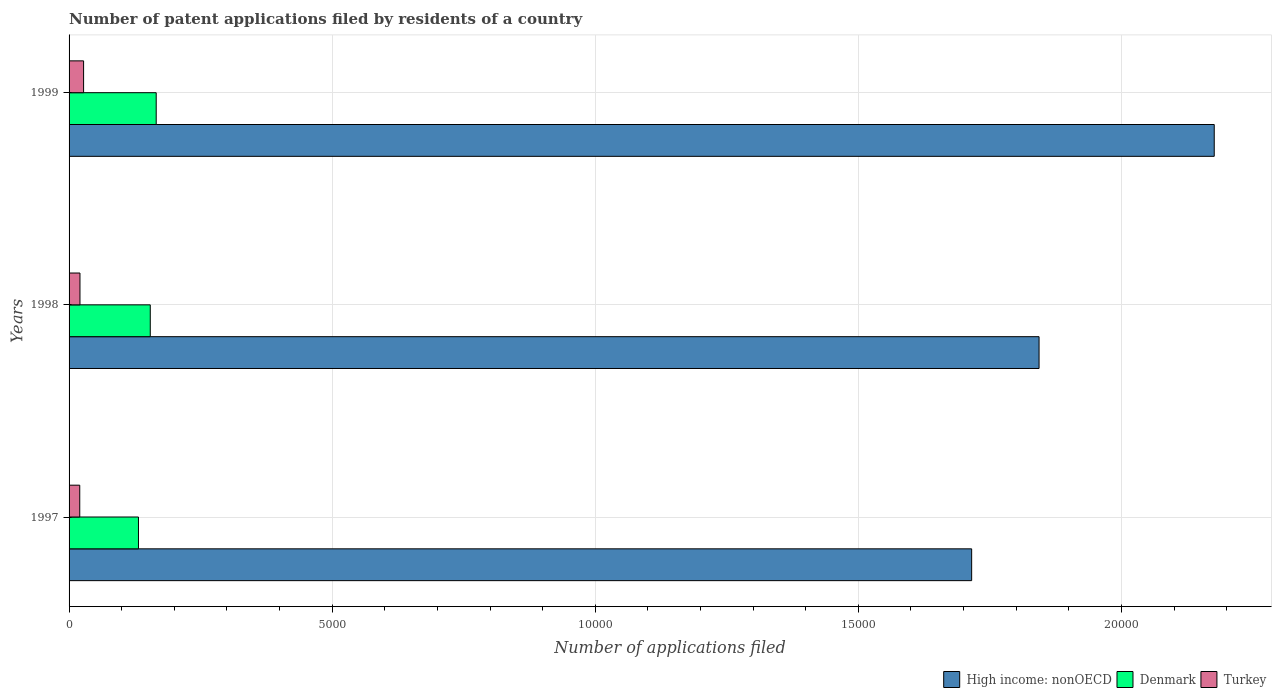How many different coloured bars are there?
Your answer should be very brief. 3. How many groups of bars are there?
Give a very brief answer. 3. Are the number of bars on each tick of the Y-axis equal?
Ensure brevity in your answer.  Yes. In how many cases, is the number of bars for a given year not equal to the number of legend labels?
Your answer should be compact. 0. What is the number of applications filed in Turkey in 1999?
Your answer should be very brief. 276. Across all years, what is the maximum number of applications filed in Turkey?
Offer a terse response. 276. Across all years, what is the minimum number of applications filed in Turkey?
Ensure brevity in your answer.  203. In which year was the number of applications filed in Denmark minimum?
Your answer should be very brief. 1997. What is the total number of applications filed in Turkey in the graph?
Your answer should be very brief. 686. What is the difference between the number of applications filed in High income: nonOECD in 1997 and that in 1999?
Your answer should be compact. -4610. What is the difference between the number of applications filed in Turkey in 1998 and the number of applications filed in Denmark in 1997?
Your response must be concise. -1112. What is the average number of applications filed in High income: nonOECD per year?
Offer a terse response. 1.91e+04. In the year 1998, what is the difference between the number of applications filed in High income: nonOECD and number of applications filed in Denmark?
Your response must be concise. 1.69e+04. In how many years, is the number of applications filed in Turkey greater than 14000 ?
Provide a succinct answer. 0. What is the ratio of the number of applications filed in Denmark in 1998 to that in 1999?
Provide a succinct answer. 0.93. Is the number of applications filed in Turkey in 1998 less than that in 1999?
Keep it short and to the point. Yes. Is the difference between the number of applications filed in High income: nonOECD in 1997 and 1998 greater than the difference between the number of applications filed in Denmark in 1997 and 1998?
Keep it short and to the point. No. What is the difference between the highest and the second highest number of applications filed in Denmark?
Make the answer very short. 113. In how many years, is the number of applications filed in Turkey greater than the average number of applications filed in Turkey taken over all years?
Offer a very short reply. 1. What does the 3rd bar from the top in 1998 represents?
Make the answer very short. High income: nonOECD. What does the 1st bar from the bottom in 1998 represents?
Offer a very short reply. High income: nonOECD. Are all the bars in the graph horizontal?
Provide a short and direct response. Yes. How many years are there in the graph?
Keep it short and to the point. 3. What is the difference between two consecutive major ticks on the X-axis?
Your response must be concise. 5000. Are the values on the major ticks of X-axis written in scientific E-notation?
Your response must be concise. No. Where does the legend appear in the graph?
Give a very brief answer. Bottom right. How are the legend labels stacked?
Offer a very short reply. Horizontal. What is the title of the graph?
Ensure brevity in your answer.  Number of patent applications filed by residents of a country. What is the label or title of the X-axis?
Provide a short and direct response. Number of applications filed. What is the Number of applications filed of High income: nonOECD in 1997?
Your answer should be compact. 1.72e+04. What is the Number of applications filed in Denmark in 1997?
Provide a short and direct response. 1319. What is the Number of applications filed of Turkey in 1997?
Make the answer very short. 203. What is the Number of applications filed in High income: nonOECD in 1998?
Offer a terse response. 1.84e+04. What is the Number of applications filed in Denmark in 1998?
Your response must be concise. 1543. What is the Number of applications filed in Turkey in 1998?
Keep it short and to the point. 207. What is the Number of applications filed of High income: nonOECD in 1999?
Your answer should be compact. 2.18e+04. What is the Number of applications filed in Denmark in 1999?
Provide a short and direct response. 1656. What is the Number of applications filed of Turkey in 1999?
Your response must be concise. 276. Across all years, what is the maximum Number of applications filed of High income: nonOECD?
Your response must be concise. 2.18e+04. Across all years, what is the maximum Number of applications filed of Denmark?
Offer a very short reply. 1656. Across all years, what is the maximum Number of applications filed of Turkey?
Ensure brevity in your answer.  276. Across all years, what is the minimum Number of applications filed of High income: nonOECD?
Make the answer very short. 1.72e+04. Across all years, what is the minimum Number of applications filed of Denmark?
Your answer should be very brief. 1319. Across all years, what is the minimum Number of applications filed of Turkey?
Keep it short and to the point. 203. What is the total Number of applications filed of High income: nonOECD in the graph?
Provide a succinct answer. 5.74e+04. What is the total Number of applications filed of Denmark in the graph?
Provide a short and direct response. 4518. What is the total Number of applications filed in Turkey in the graph?
Offer a very short reply. 686. What is the difference between the Number of applications filed in High income: nonOECD in 1997 and that in 1998?
Offer a terse response. -1281. What is the difference between the Number of applications filed of Denmark in 1997 and that in 1998?
Your response must be concise. -224. What is the difference between the Number of applications filed in High income: nonOECD in 1997 and that in 1999?
Give a very brief answer. -4610. What is the difference between the Number of applications filed of Denmark in 1997 and that in 1999?
Your response must be concise. -337. What is the difference between the Number of applications filed of Turkey in 1997 and that in 1999?
Make the answer very short. -73. What is the difference between the Number of applications filed of High income: nonOECD in 1998 and that in 1999?
Your answer should be very brief. -3329. What is the difference between the Number of applications filed in Denmark in 1998 and that in 1999?
Your answer should be compact. -113. What is the difference between the Number of applications filed of Turkey in 1998 and that in 1999?
Provide a succinct answer. -69. What is the difference between the Number of applications filed in High income: nonOECD in 1997 and the Number of applications filed in Denmark in 1998?
Ensure brevity in your answer.  1.56e+04. What is the difference between the Number of applications filed in High income: nonOECD in 1997 and the Number of applications filed in Turkey in 1998?
Your response must be concise. 1.69e+04. What is the difference between the Number of applications filed in Denmark in 1997 and the Number of applications filed in Turkey in 1998?
Offer a terse response. 1112. What is the difference between the Number of applications filed of High income: nonOECD in 1997 and the Number of applications filed of Denmark in 1999?
Your answer should be compact. 1.55e+04. What is the difference between the Number of applications filed of High income: nonOECD in 1997 and the Number of applications filed of Turkey in 1999?
Offer a terse response. 1.69e+04. What is the difference between the Number of applications filed of Denmark in 1997 and the Number of applications filed of Turkey in 1999?
Your response must be concise. 1043. What is the difference between the Number of applications filed of High income: nonOECD in 1998 and the Number of applications filed of Denmark in 1999?
Offer a terse response. 1.68e+04. What is the difference between the Number of applications filed in High income: nonOECD in 1998 and the Number of applications filed in Turkey in 1999?
Ensure brevity in your answer.  1.82e+04. What is the difference between the Number of applications filed of Denmark in 1998 and the Number of applications filed of Turkey in 1999?
Give a very brief answer. 1267. What is the average Number of applications filed in High income: nonOECD per year?
Your answer should be very brief. 1.91e+04. What is the average Number of applications filed in Denmark per year?
Your answer should be compact. 1506. What is the average Number of applications filed in Turkey per year?
Your response must be concise. 228.67. In the year 1997, what is the difference between the Number of applications filed in High income: nonOECD and Number of applications filed in Denmark?
Provide a succinct answer. 1.58e+04. In the year 1997, what is the difference between the Number of applications filed in High income: nonOECD and Number of applications filed in Turkey?
Give a very brief answer. 1.70e+04. In the year 1997, what is the difference between the Number of applications filed of Denmark and Number of applications filed of Turkey?
Provide a succinct answer. 1116. In the year 1998, what is the difference between the Number of applications filed in High income: nonOECD and Number of applications filed in Denmark?
Your response must be concise. 1.69e+04. In the year 1998, what is the difference between the Number of applications filed in High income: nonOECD and Number of applications filed in Turkey?
Offer a terse response. 1.82e+04. In the year 1998, what is the difference between the Number of applications filed of Denmark and Number of applications filed of Turkey?
Provide a succinct answer. 1336. In the year 1999, what is the difference between the Number of applications filed in High income: nonOECD and Number of applications filed in Denmark?
Offer a terse response. 2.01e+04. In the year 1999, what is the difference between the Number of applications filed in High income: nonOECD and Number of applications filed in Turkey?
Make the answer very short. 2.15e+04. In the year 1999, what is the difference between the Number of applications filed of Denmark and Number of applications filed of Turkey?
Ensure brevity in your answer.  1380. What is the ratio of the Number of applications filed of High income: nonOECD in 1997 to that in 1998?
Give a very brief answer. 0.93. What is the ratio of the Number of applications filed in Denmark in 1997 to that in 1998?
Give a very brief answer. 0.85. What is the ratio of the Number of applications filed of Turkey in 1997 to that in 1998?
Your answer should be very brief. 0.98. What is the ratio of the Number of applications filed of High income: nonOECD in 1997 to that in 1999?
Your answer should be compact. 0.79. What is the ratio of the Number of applications filed of Denmark in 1997 to that in 1999?
Provide a short and direct response. 0.8. What is the ratio of the Number of applications filed of Turkey in 1997 to that in 1999?
Offer a very short reply. 0.74. What is the ratio of the Number of applications filed of High income: nonOECD in 1998 to that in 1999?
Offer a terse response. 0.85. What is the ratio of the Number of applications filed of Denmark in 1998 to that in 1999?
Ensure brevity in your answer.  0.93. What is the difference between the highest and the second highest Number of applications filed of High income: nonOECD?
Make the answer very short. 3329. What is the difference between the highest and the second highest Number of applications filed in Denmark?
Give a very brief answer. 113. What is the difference between the highest and the second highest Number of applications filed in Turkey?
Ensure brevity in your answer.  69. What is the difference between the highest and the lowest Number of applications filed of High income: nonOECD?
Your answer should be compact. 4610. What is the difference between the highest and the lowest Number of applications filed of Denmark?
Provide a succinct answer. 337. What is the difference between the highest and the lowest Number of applications filed of Turkey?
Your response must be concise. 73. 